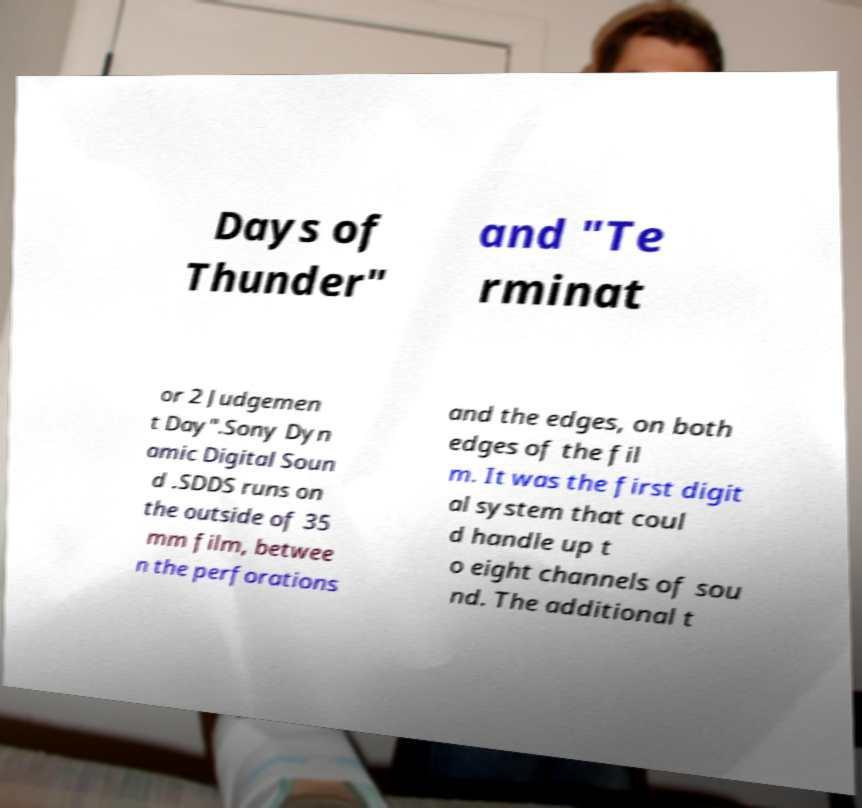Could you extract and type out the text from this image? Days of Thunder" and "Te rminat or 2 Judgemen t Day".Sony Dyn amic Digital Soun d .SDDS runs on the outside of 35 mm film, betwee n the perforations and the edges, on both edges of the fil m. It was the first digit al system that coul d handle up t o eight channels of sou nd. The additional t 